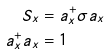Convert formula to latex. <formula><loc_0><loc_0><loc_500><loc_500>S _ { x } & = a _ { x } ^ { + } \sigma a _ { x } \\ a _ { x } ^ { + } a _ { x } & = 1</formula> 